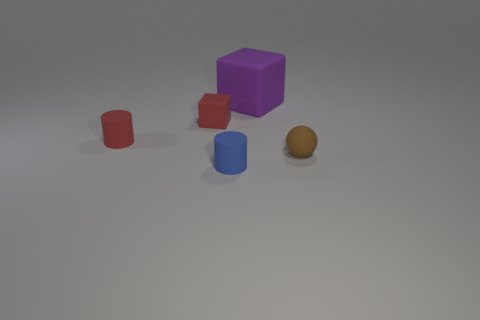There is a object that is the same color as the tiny block; what is it made of?
Your answer should be compact. Rubber. What number of other things are there of the same size as the purple matte thing?
Make the answer very short. 0. What size is the object that is to the right of the purple rubber object?
Keep it short and to the point. Small. There is a tiny blue thing that is made of the same material as the large block; what shape is it?
Your answer should be compact. Cylinder. Is there anything else that has the same color as the big thing?
Your answer should be very brief. No. There is a tiny thing that is right of the cylinder in front of the brown sphere; what color is it?
Make the answer very short. Brown. What number of large objects are gray cylinders or blue things?
Ensure brevity in your answer.  0. What material is the other tiny object that is the same shape as the purple matte object?
Provide a short and direct response. Rubber. Is there anything else that is the same material as the tiny red cylinder?
Make the answer very short. Yes. The large object has what color?
Provide a succinct answer. Purple. 